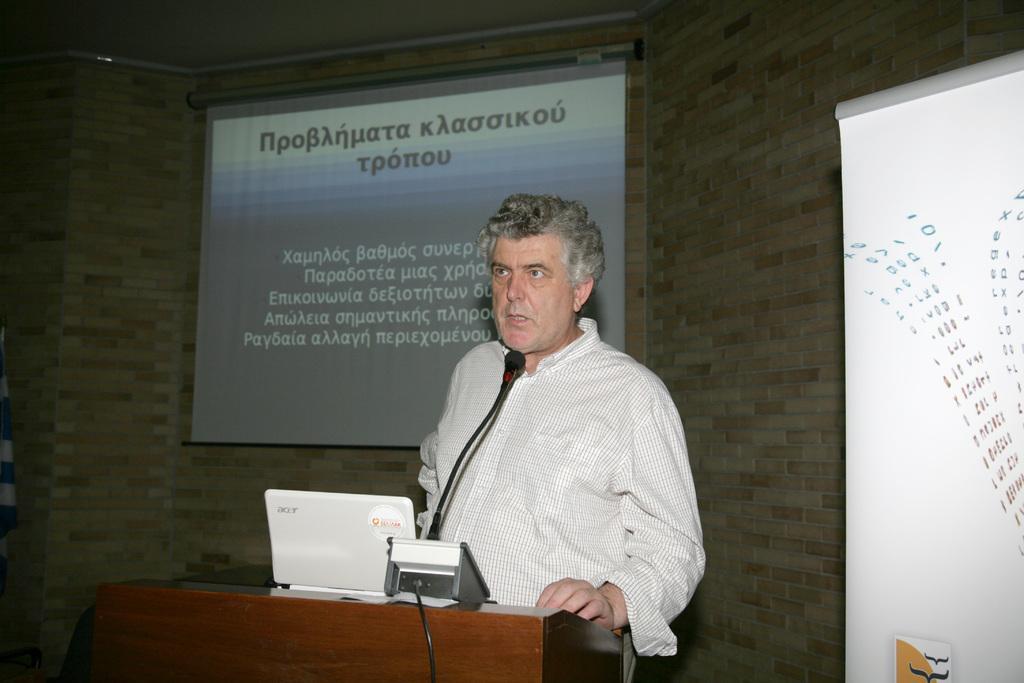Describe this image in one or two sentences. In the center of the image a man is standing in-front of podium. On podium we can see laptop, mic, wire. In the background of the image we can see screen, wall, board, light. 